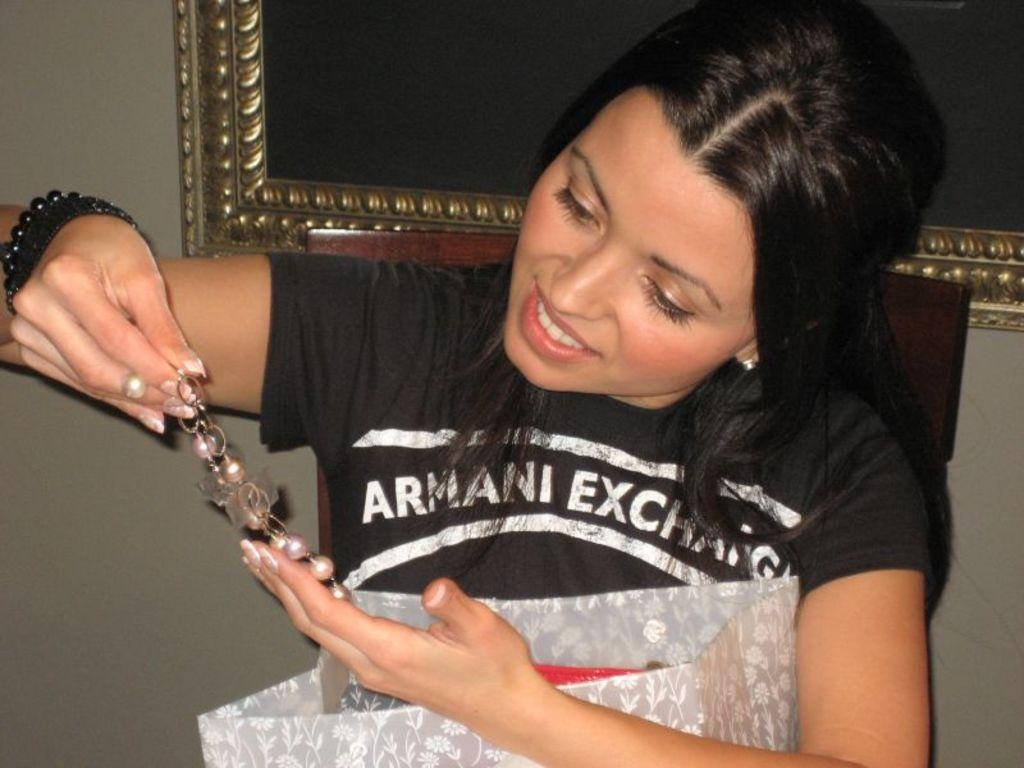Who is the main subject in the image? There is a girl in the image. What is the girl doing in the image? The girl is sitting on a chair. What is the girl holding in her hands? The girl is holding a cover and an object. What can be seen in the background of the image? There is a frame attached to the wall in the background of the image. How does the girl push the ant away from her in the image? There is no ant present in the image, so the girl cannot push it away. 